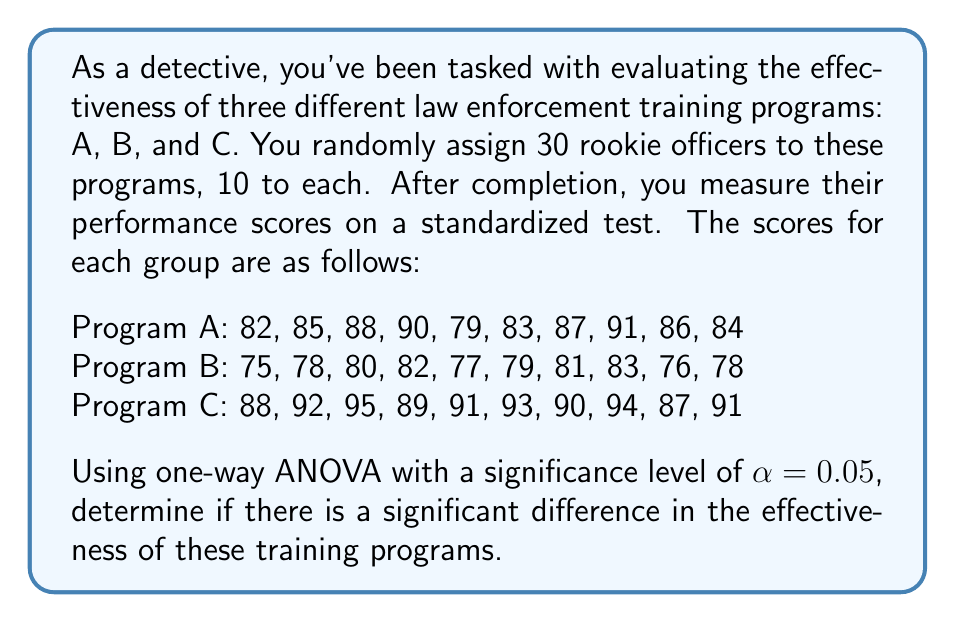Teach me how to tackle this problem. To solve this problem using one-way ANOVA, we'll follow these steps:

1. Calculate the sum of squares between groups (SSB), within groups (SSW), and total (SST).
2. Calculate the degrees of freedom for between groups (dfB), within groups (dfW), and total (dfT).
3. Calculate the mean squares for between groups (MSB) and within groups (MSW).
4. Calculate the F-statistic.
5. Compare the F-statistic to the critical F-value.

Step 1: Calculate sum of squares

First, we need to calculate the grand mean:
$$ \bar{X} = \frac{2550}{30} = 85 $$

Now, we can calculate SSB, SSW, and SST:

SSB = $\sum_{i=1}^{k} n_i(\bar{X_i} - \bar{X})^2$
$$ SSB = 10(85.5 - 85)^2 + 10(78.9 - 85)^2 + 10(91.0 - 85)^2 = 912.2 $$

SSW = $\sum_{i=1}^{k} \sum_{j=1}^{n_i} (X_{ij} - \bar{X_i})^2$
$$ SSW = 140.5 + 68.9 + 70.0 = 279.4 $$

SST = SSB + SSW = 912.2 + 279.4 = 1191.6

Step 2: Calculate degrees of freedom

dfB = k - 1 = 3 - 1 = 2
dfW = N - k = 30 - 3 = 27
dfT = N - 1 = 30 - 1 = 29

Step 3: Calculate mean squares

$$ MSB = \frac{SSB}{dfB} = \frac{912.2}{2} = 456.1 $$
$$ MSW = \frac{SSW}{dfW} = \frac{279.4}{27} = 10.35 $$

Step 4: Calculate F-statistic

$$ F = \frac{MSB}{MSW} = \frac{456.1}{10.35} = 44.07 $$

Step 5: Compare F-statistic to critical F-value

The critical F-value for α = 0.05, dfB = 2, and dfW = 27 is approximately 3.35.

Since our calculated F-statistic (44.07) is greater than the critical F-value (3.35), we reject the null hypothesis.
Answer: There is a significant difference in the effectiveness of the three law enforcement training programs (F(2,27) = 44.07, p < 0.05). 